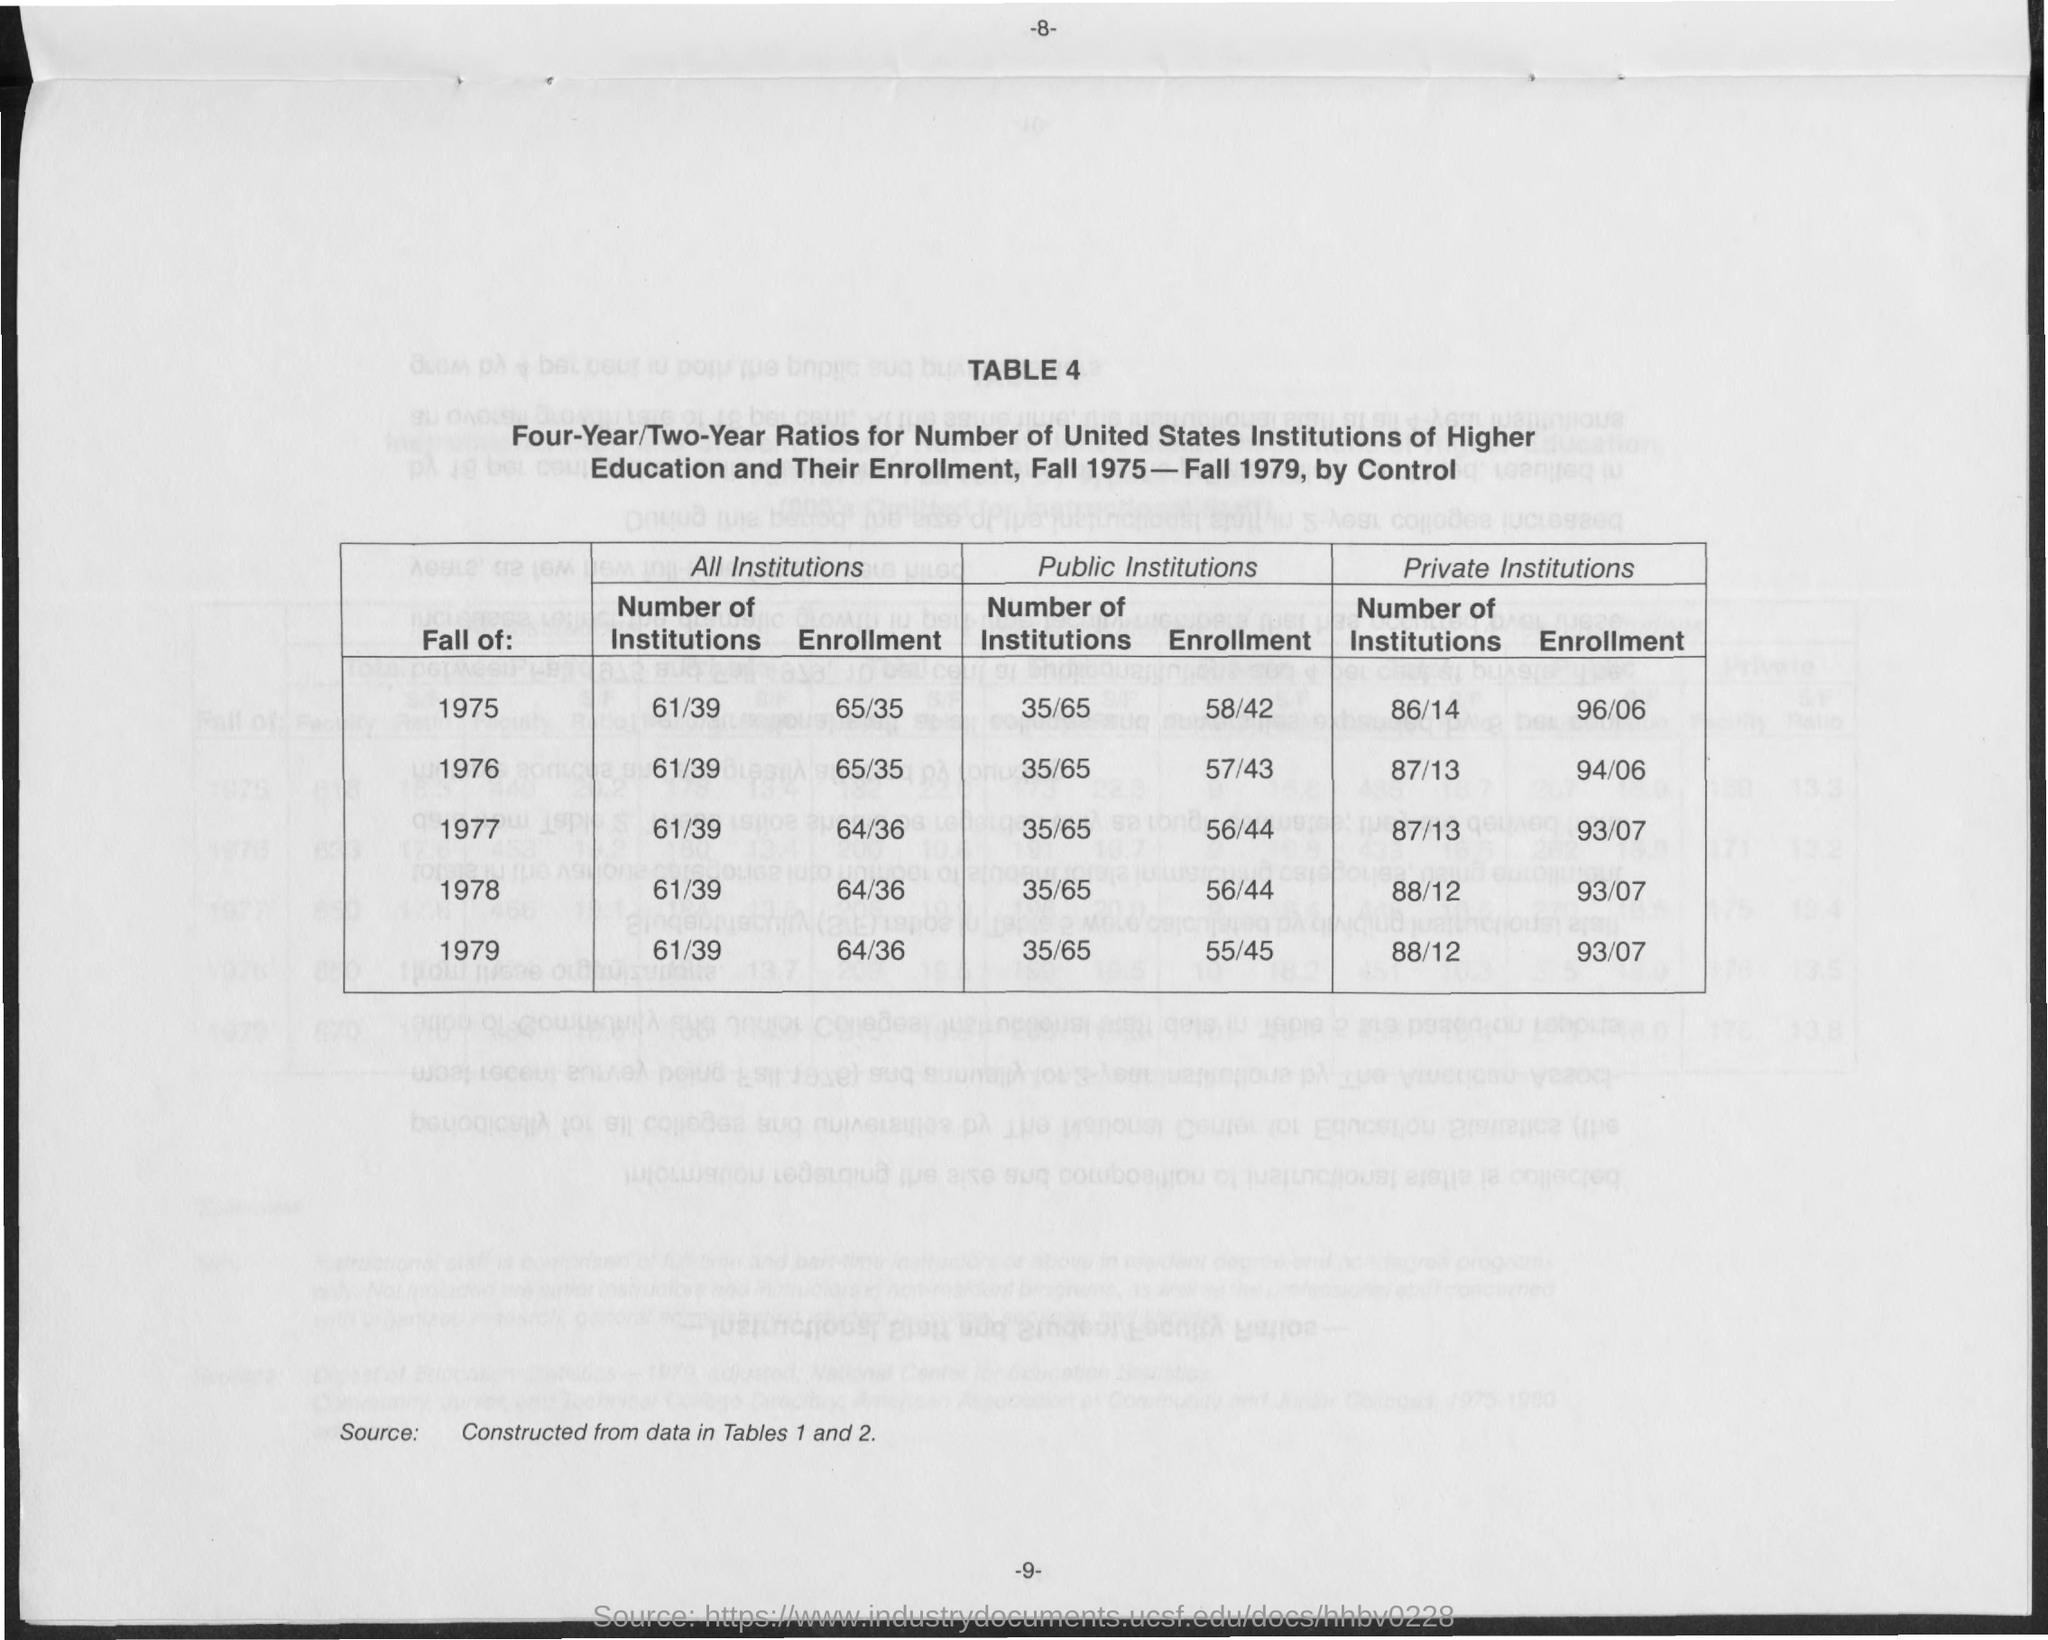Point out several critical features in this image. What is the number of the table? It is 4.. The "Four-Year/Two Year Ratio" of enrollment at all institutions during 1979 was 64 to 36. In 1978, out of the total number of institutions under the category of "Public Institutions," 35 of them had a four-year undergraduate program, while the remaining 65 had a two-year undergraduate program. The "Four-Year/Two Year Ratio" of enrollment at public institutions during 1975 was 58 to 42. The "Four-Year/Two Year Ratio" of enrollment in public institutions during 1978 was 56 to 44. 